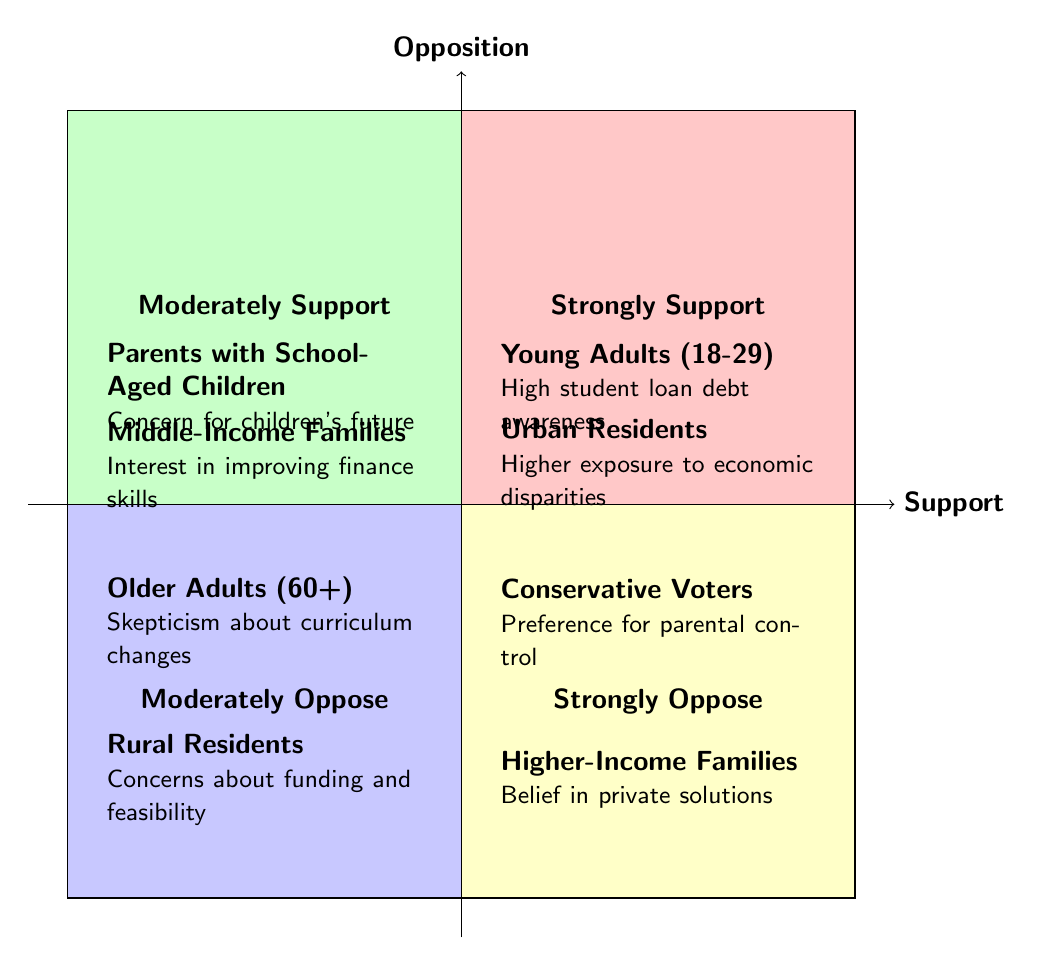What demographic group is in the "Strongly Support" quadrant? The "Strongly Support" quadrant mentions two demographic groups: "Young Adults (18-29)" and "Urban Residents". You can find these directly listed in the quadrant.
Answer: Young Adults (18-29), Urban Residents How many demographics are in the "Moderately Oppose" quadrant? In the "Moderately Oppose" quadrant, there are two demographic groups mentioned: "Older Adults (60+)" and "Rural Residents." The count of groups is simply summed from the provided entries in that quadrant.
Answer: 2 What is the primary reason for "Conservative Voters" opposing financial literacy education? The reason listed for "Conservative Voters" in the "Strongly Oppose" quadrant is their preference for parental control over education content. This detail is specified directly in the quadrant.
Answer: Preference for parental control Which demographic group shows moderate support due to concerns about children’s future? The "Parents with School-Aged Children" are noted in the "Moderately Support" quadrant with the specific reason being their concern for children's future financial stability. This group is clearly stated in that quadrant.
Answer: Parents with School-Aged Children What is one common concern among "Rural Residents" regarding financial literacy education? "Rural Residents" express concerns about funding and feasibility in smaller school districts, which is specifically mentioned in their entry in the "Moderately Oppose" quadrant. This reasoning indicates potential challenges they face.
Answer: Funding and feasibility Which quadrant includes "Higher-Income Families"? The "Higher-Income Families" are located in the "Strongly Oppose" quadrant as they believe in private education and financial management solutions. This indicates their stance against incorporating financial literacy in public education.
Answer: Strongly Oppose What two demographic groups strongly support financial literacy education and why? The groups are "Young Adults (18-29)" and "Urban Residents." Their support is attributed to high student loan debt awareness and exposure to economic disparities respectively, as shown in the "Strongly Support" quadrant.
Answer: Young Adults (18-29), Urban Residents Is "Middle-Income Families" supporting or opposing financial literacy education? "Middle-Income Families" are in the "Moderately Support" quadrant, indicating support for financial literacy education due to their interest in improving personal finance management skills. This placement denotes a favorable stance.
Answer: Supporting 